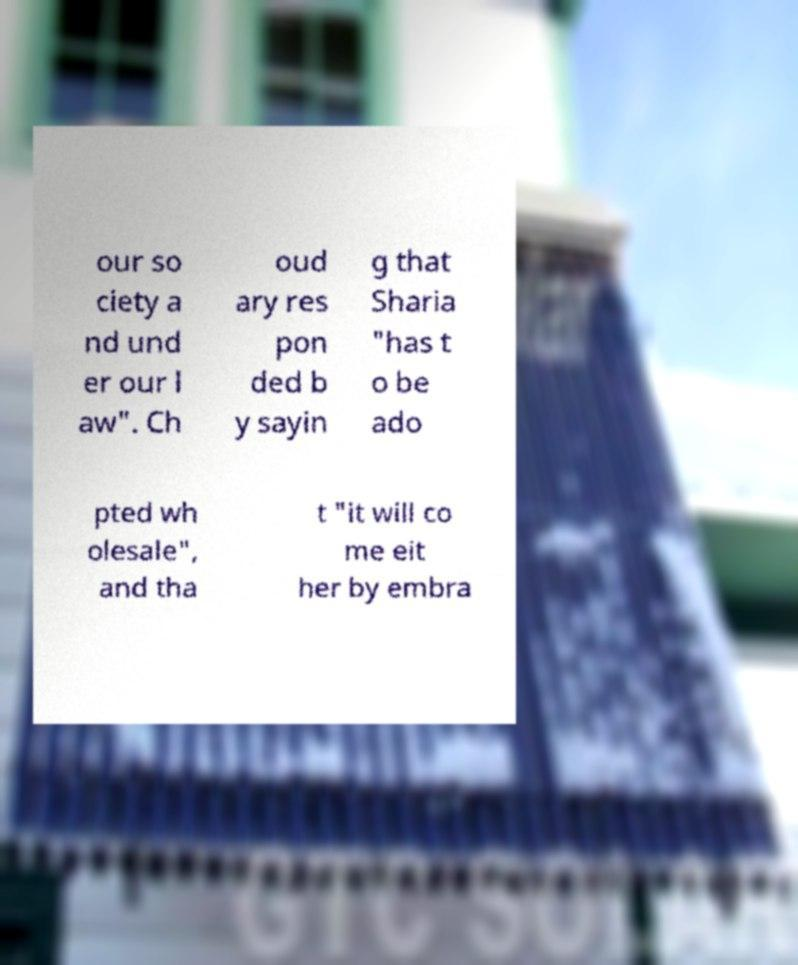I need the written content from this picture converted into text. Can you do that? our so ciety a nd und er our l aw". Ch oud ary res pon ded b y sayin g that Sharia "has t o be ado pted wh olesale", and tha t "it will co me eit her by embra 